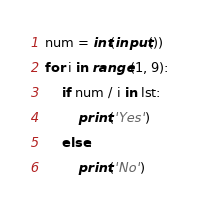<code> <loc_0><loc_0><loc_500><loc_500><_Python_>num = int(input())
for i in range(1, 9):
    if num / i in lst:
        print('Yes')
    else:
        print('No')
</code> 